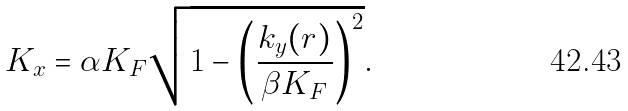Convert formula to latex. <formula><loc_0><loc_0><loc_500><loc_500>K _ { x } = \alpha K _ { F } \sqrt { 1 - \left ( \frac { k _ { y } ( r ) } { \beta K _ { F } } \right ) ^ { 2 } } .</formula> 